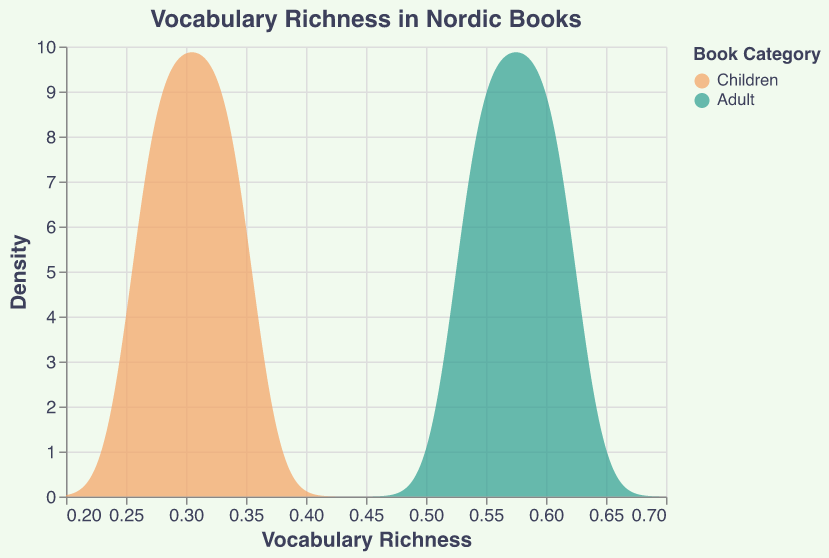What is the title of the density plot? The title is displayed at the top of the figure in a larger font size than the other text. It describes what the plot is about.
Answer: Vocabulary Richness in Nordic Books What do the colors in the plot represent? The legend on the right side of the plot shows that colors represent the book categories: orange for "Children" and green for "Adult".
Answer: Book Categories What is the range of Vocabulary Richness values displayed on the x-axis? The x-axis ranges from the minimum value of 0.2 to the maximum value of 0.7, as indicated by the axis labels.
Answer: 0.2 to 0.7 Which category shows higher vocabulary richness on average? The density plot for "Adult" books is centered around higher vocabulary richness values compared to "Children" books, suggesting that "Adult" books have a higher average vocabulary richness.
Answer: Adult What is the peak density value for Adult books? The peak of the green density region appears to align with the highest density value on the y-axis, indicating this value. Based on the plot, this value seems to be around 10 density units.
Answer: 10 Do Children’s books show any density above a vocabulary richness value of 0.5? By observing the orange region in the density plot, it appears that the density for Children's books is almost zero at vocabulary richness values above 0.5.
Answer: No Is the vocabulary richness of the Children category concentrated around a particular value? The density plot shows a peak for the "Children" category around the 0.3 - 0.35 mark, indicating a concentration of vocabulary richness values in that range.
Answer: Around 0.3 - 0.35 What can you infer about the distribution of vocabulary richness in Adult books? The green density area for "Adult" books is more spread out and spans higher vocabulary richness values than the orange area for "Children" books, suggesting a wider range and generally higher vocabulary use in Adult books.
Answer: Wider and higher span Are there any areas where the density for both categories overlap significantly? The density plots for "Children" and "Adult" books overlap around the vocabulary richness values 0.53 to 0.55, as both categories have non-zero density in this range.
Answer: Around 0.53 to 0.55 How do density values below 0.3 differ between the two categories? In the plot, the density for the Adult category is zero for vocabulary richness values below 0.3, while the Children category still shows some density, indicating that low vocabulary richness values are present only in Children’s books.
Answer: Only in Children’s books 